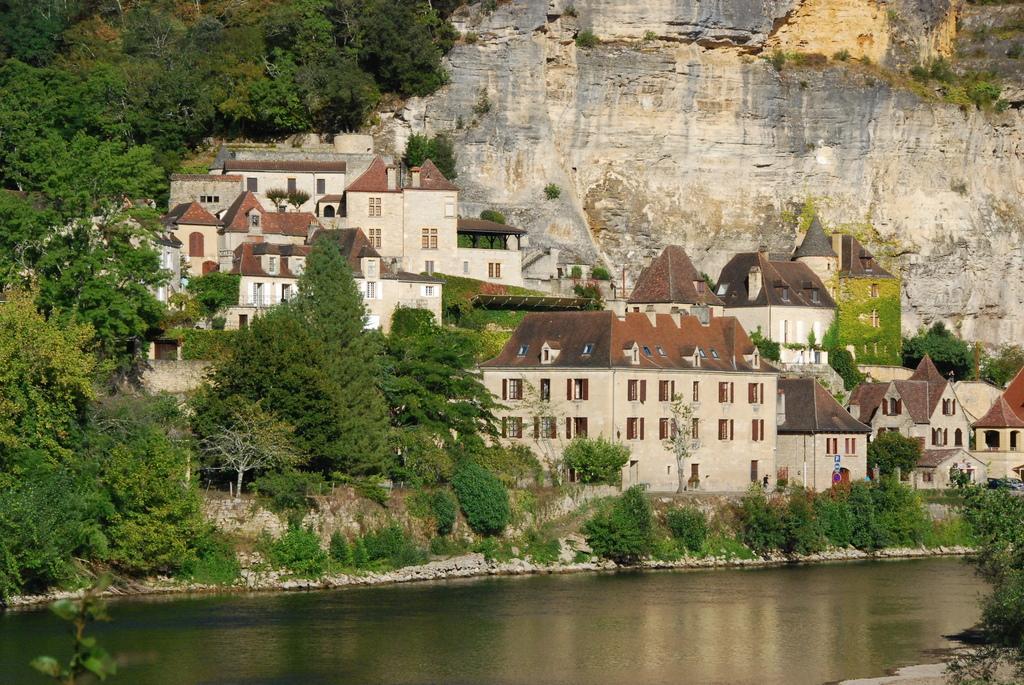In one or two sentences, can you explain what this image depicts? In this picture we can see water,buildings and trees. 